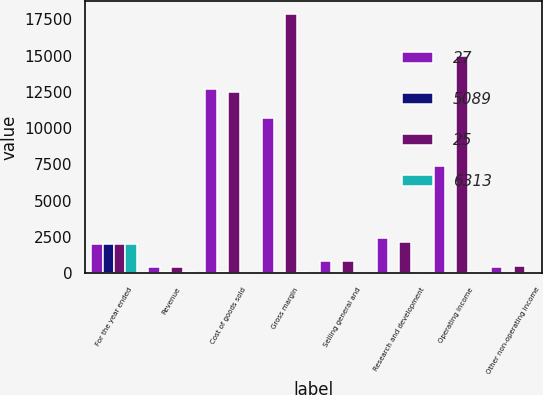Convert chart to OTSL. <chart><loc_0><loc_0><loc_500><loc_500><stacked_bar_chart><ecel><fcel>For the year ended<fcel>Revenue<fcel>Cost of goods sold<fcel>Gross margin<fcel>Selling general and<fcel>Research and development<fcel>Operating income<fcel>Other non-operating income<nl><fcel>27<fcel>2019<fcel>435<fcel>12704<fcel>10702<fcel>836<fcel>2441<fcel>7376<fcel>405<nl><fcel>5089<fcel>2019<fcel>100<fcel>54<fcel>46<fcel>4<fcel>10<fcel>32<fcel>2<nl><fcel>25<fcel>2018<fcel>435<fcel>12500<fcel>17891<fcel>813<fcel>2141<fcel>14994<fcel>465<nl><fcel>6313<fcel>2018<fcel>100<fcel>41<fcel>59<fcel>3<fcel>7<fcel>49<fcel>2<nl></chart> 